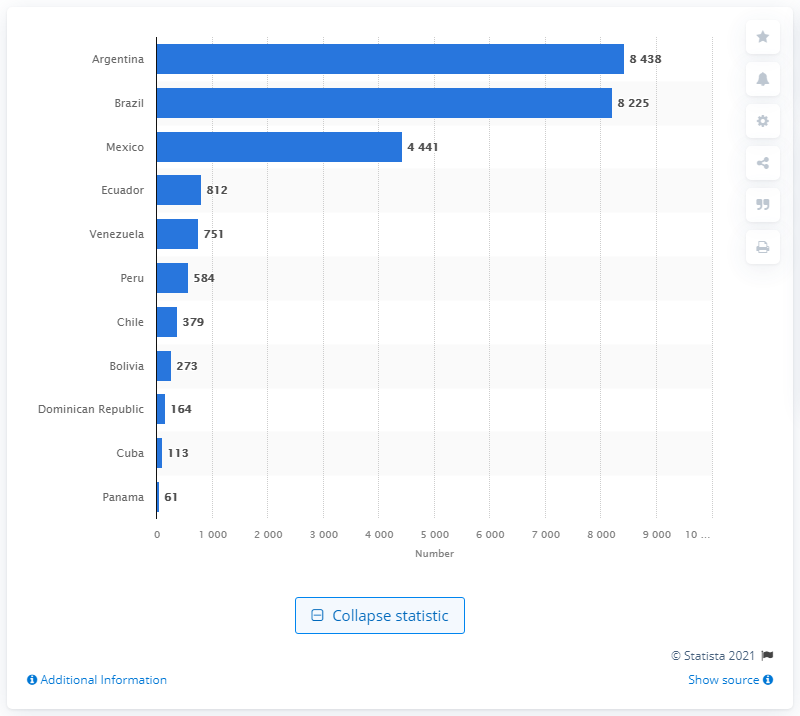Point out several critical features in this image. In 2015, Brazil was ranked as the top health center and hospital in Latin America, according to a list. According to the list of health centers and hospitals in Latin America in 2015, Argentina ranked first. 